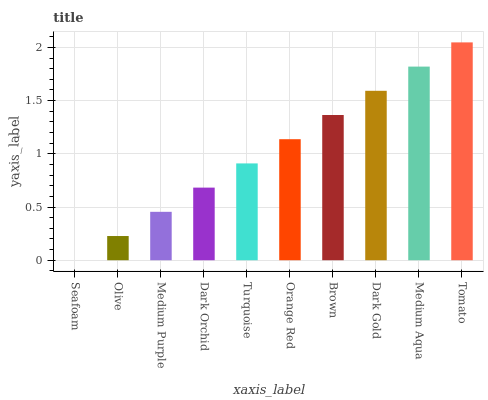Is Olive the minimum?
Answer yes or no. No. Is Olive the maximum?
Answer yes or no. No. Is Olive greater than Seafoam?
Answer yes or no. Yes. Is Seafoam less than Olive?
Answer yes or no. Yes. Is Seafoam greater than Olive?
Answer yes or no. No. Is Olive less than Seafoam?
Answer yes or no. No. Is Orange Red the high median?
Answer yes or no. Yes. Is Turquoise the low median?
Answer yes or no. Yes. Is Brown the high median?
Answer yes or no. No. Is Medium Purple the low median?
Answer yes or no. No. 